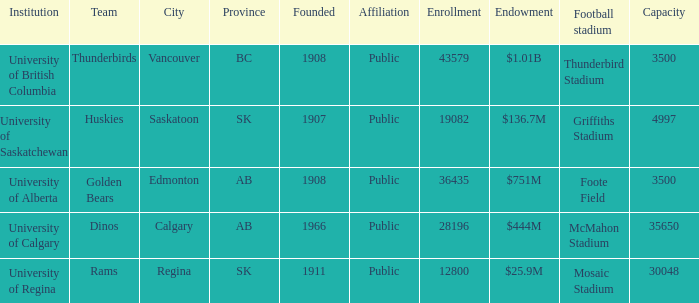Which institution has an endowment of $25.9m? University of Regina. 